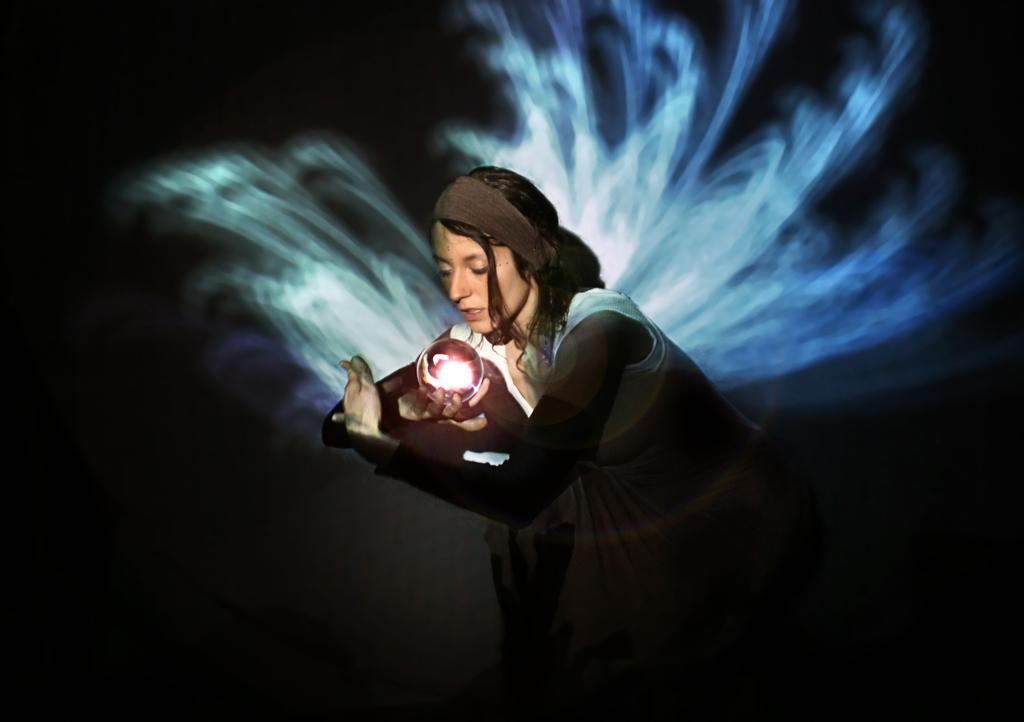Who is the main subject in the image? There is a woman in the image. What is the woman holding in the image? The woman is holding a plasma ball. What can be observed about the background of the image? The background of the image is dark. Can you see a receipt in the woman's hand in the image? No, there is no receipt visible in the image. The woman is holding a plasma ball, not a receipt. 